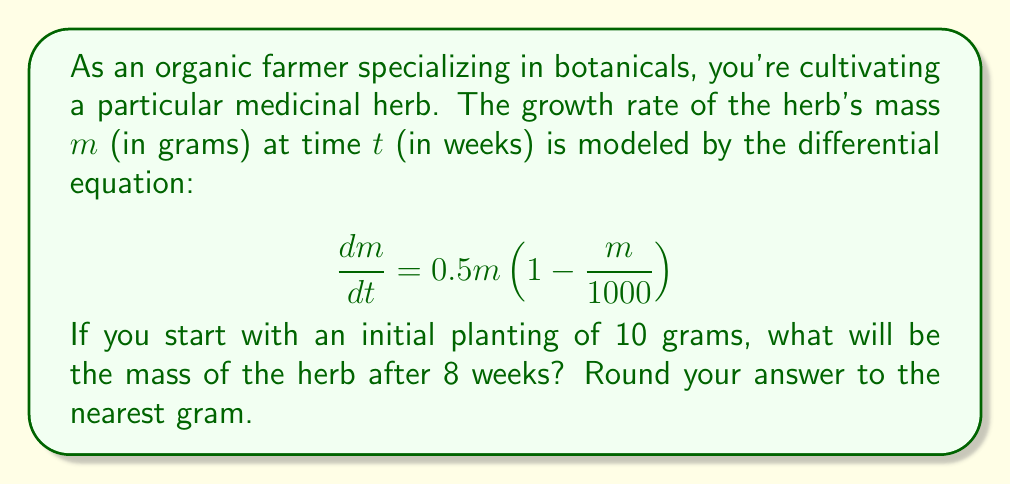Give your solution to this math problem. To solve this problem, we need to use the logistic growth model and solve the differential equation:

1) The given differential equation is a logistic growth model:
   $$\frac{dm}{dt} = 0.5m\left(1 - \frac{m}{1000}\right)$$

2) The general solution for this type of equation is:
   $$m(t) = \frac{K}{1 + Ce^{-rt}}$$
   where $K$ is the carrying capacity (1000 in this case), $r$ is the growth rate (0.5), and $C$ is a constant we need to determine.

3) We know the initial condition: $m(0) = 10$. Let's use this to find $C$:
   $$10 = \frac{1000}{1 + C}$$
   $$C = 99$$

4) Now our specific solution is:
   $$m(t) = \frac{1000}{1 + 99e^{-0.5t}}$$

5) To find the mass after 8 weeks, we substitute $t = 8$:
   $$m(8) = \frac{1000}{1 + 99e^{-0.5(8)}}$$

6) Calculating this:
   $$m(8) = \frac{1000}{1 + 99e^{-4}} \approx 179.84$$

7) Rounding to the nearest gram:
   $m(8) \approx 180$ grams
Answer: 180 grams 